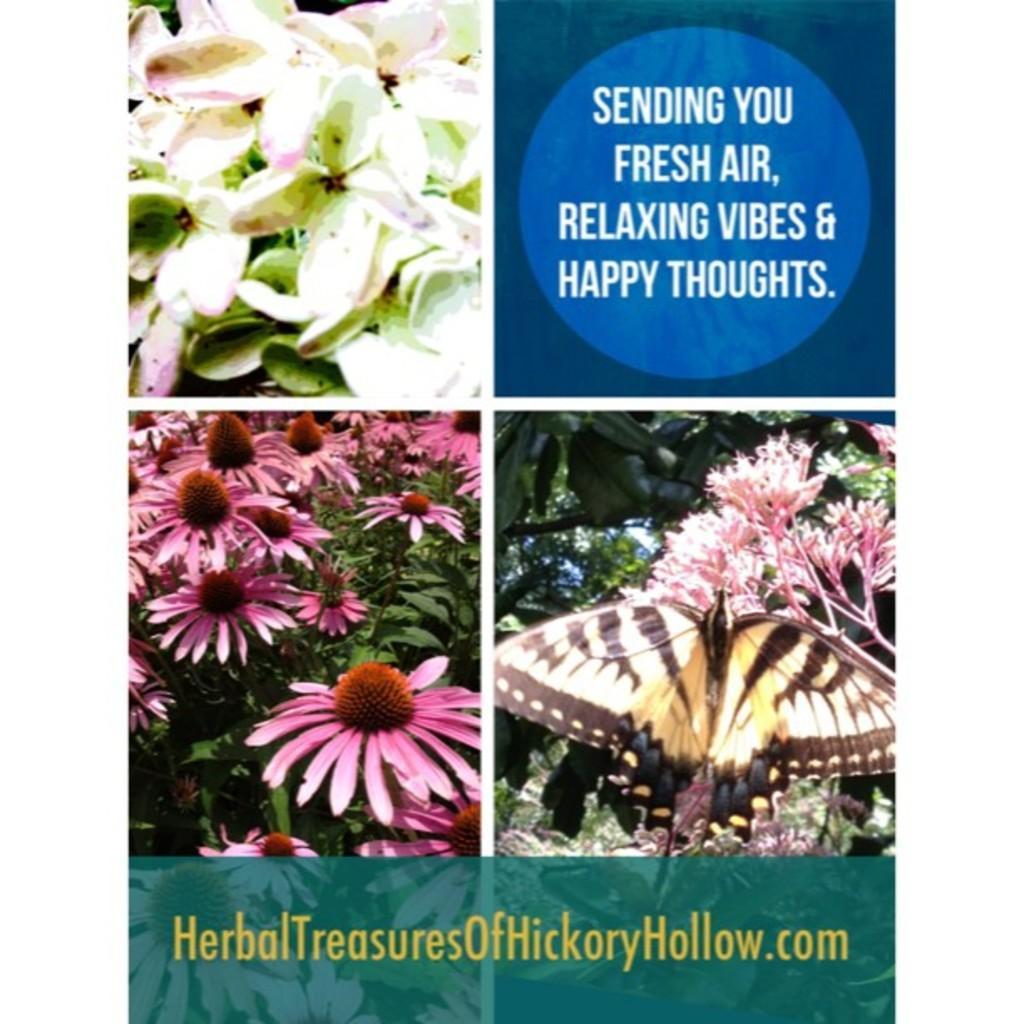Can you describe this image briefly? In this image I can see it is the photo collage. On the left side there are flowers, on the right side there is the butterfly on the flowers. At the bottom there is the website name. 